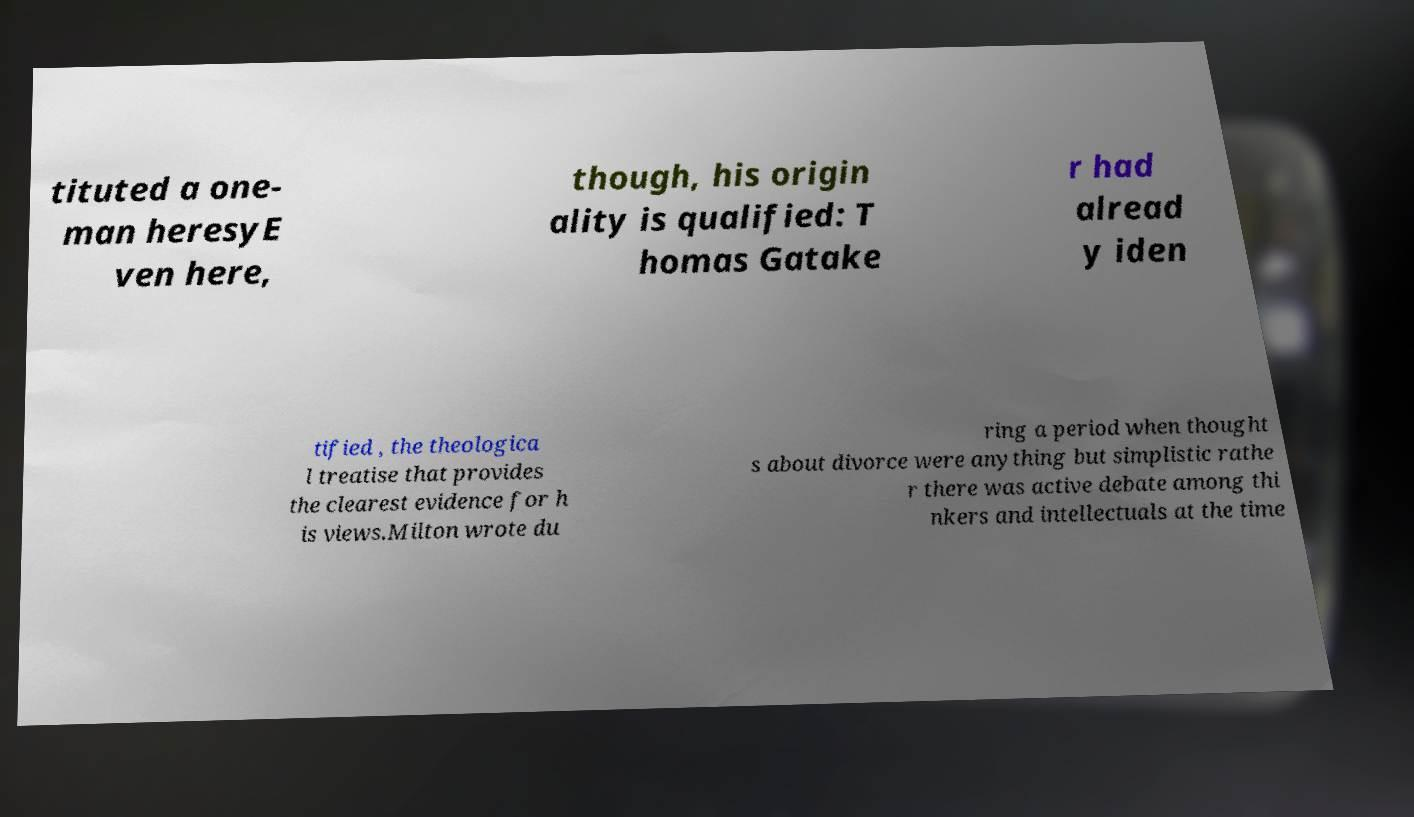I need the written content from this picture converted into text. Can you do that? tituted a one- man heresyE ven here, though, his origin ality is qualified: T homas Gatake r had alread y iden tified , the theologica l treatise that provides the clearest evidence for h is views.Milton wrote du ring a period when thought s about divorce were anything but simplistic rathe r there was active debate among thi nkers and intellectuals at the time 